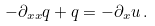Convert formula to latex. <formula><loc_0><loc_0><loc_500><loc_500>- \partial _ { x x } q + q = - \partial _ { x } u \, .</formula> 